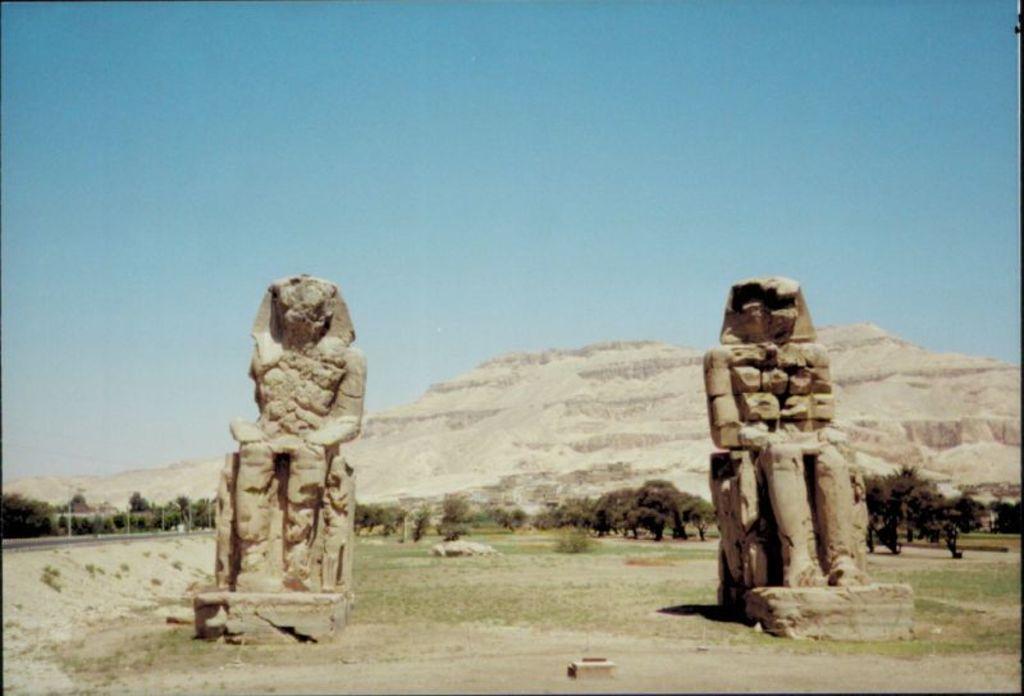How would you summarize this image in a sentence or two? In this image I see 2 statues and I see the ground. In the background I see number of trees, mountains and the clear sky. 